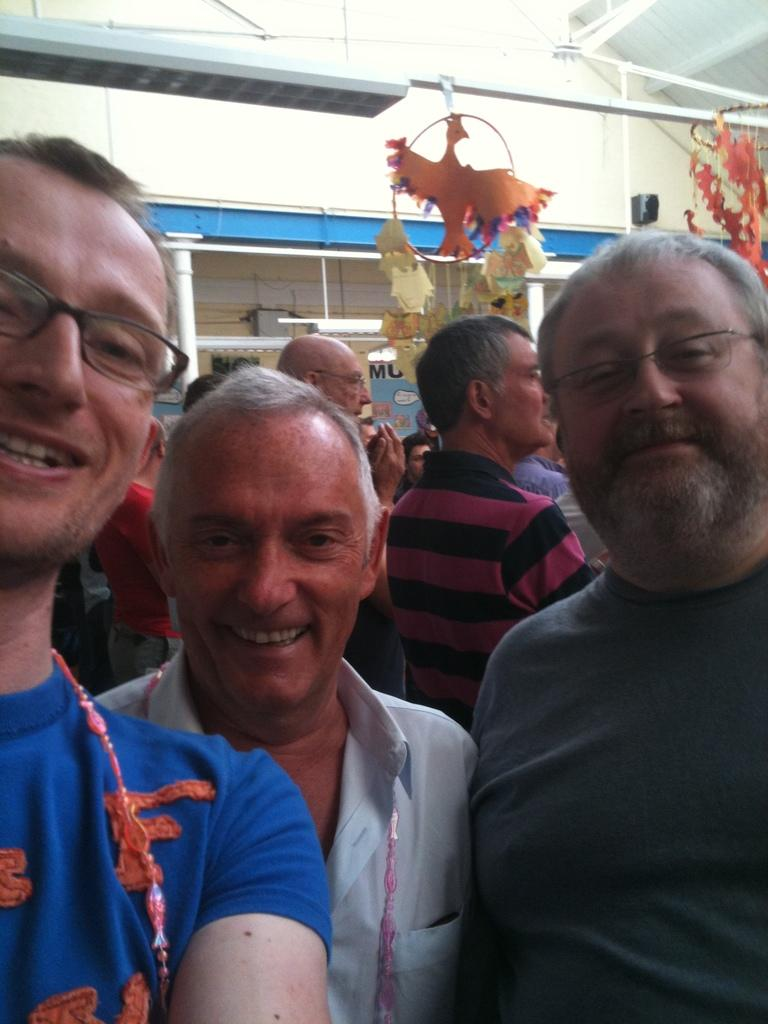What is happening in the foreground of the image? There are people standing in the foreground of the image. What is happening in the background of the image? There are people standing at the back of the image. What objects can be seen in the image? Poles are visible in the image. What type of pickle is being used as a prop by the people in the image? There is no pickle present in the image. What type of leaf is being held by the people in the image? There is no leaf present in the image. 